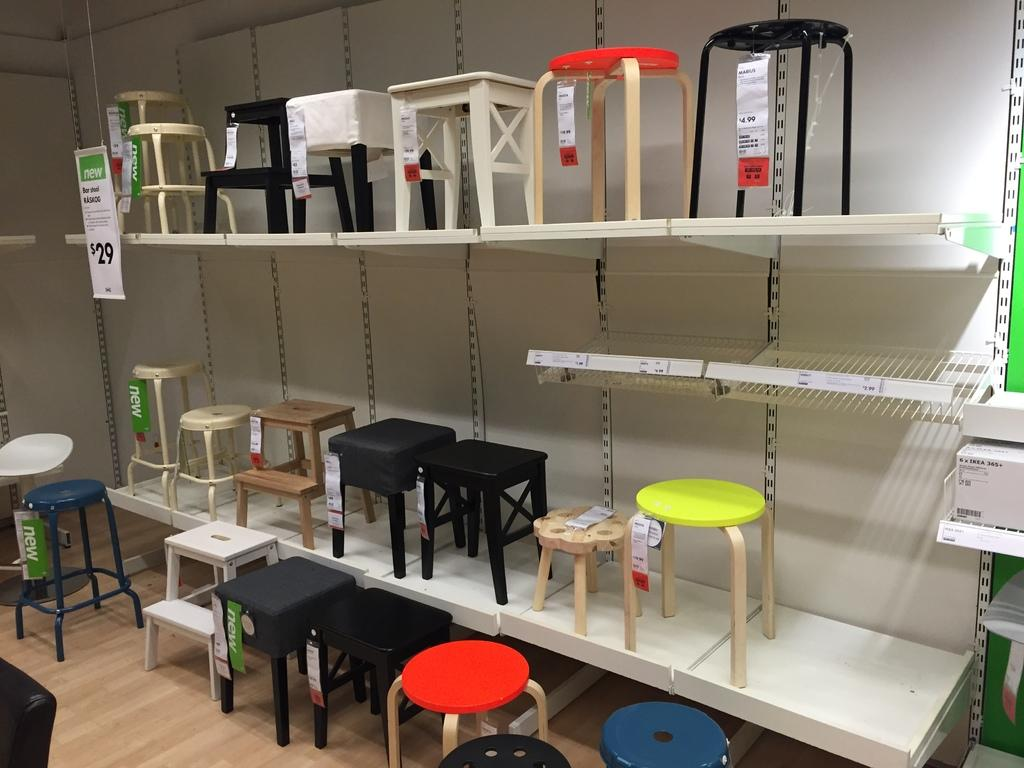How many racks are visible in the image? There are two racks in the image. What can be found on the racks? There are different kinds of stools on the racks. Is there any indication of the price of the stools? Yes, there is a price tag on one of the racks. What can be seen at the bottom of the image? At the bottom of the image, there are stools of different sizes. What type of bird can be seen flying over the racks in the image? There are no birds visible in the image; it only features racks and stools. 